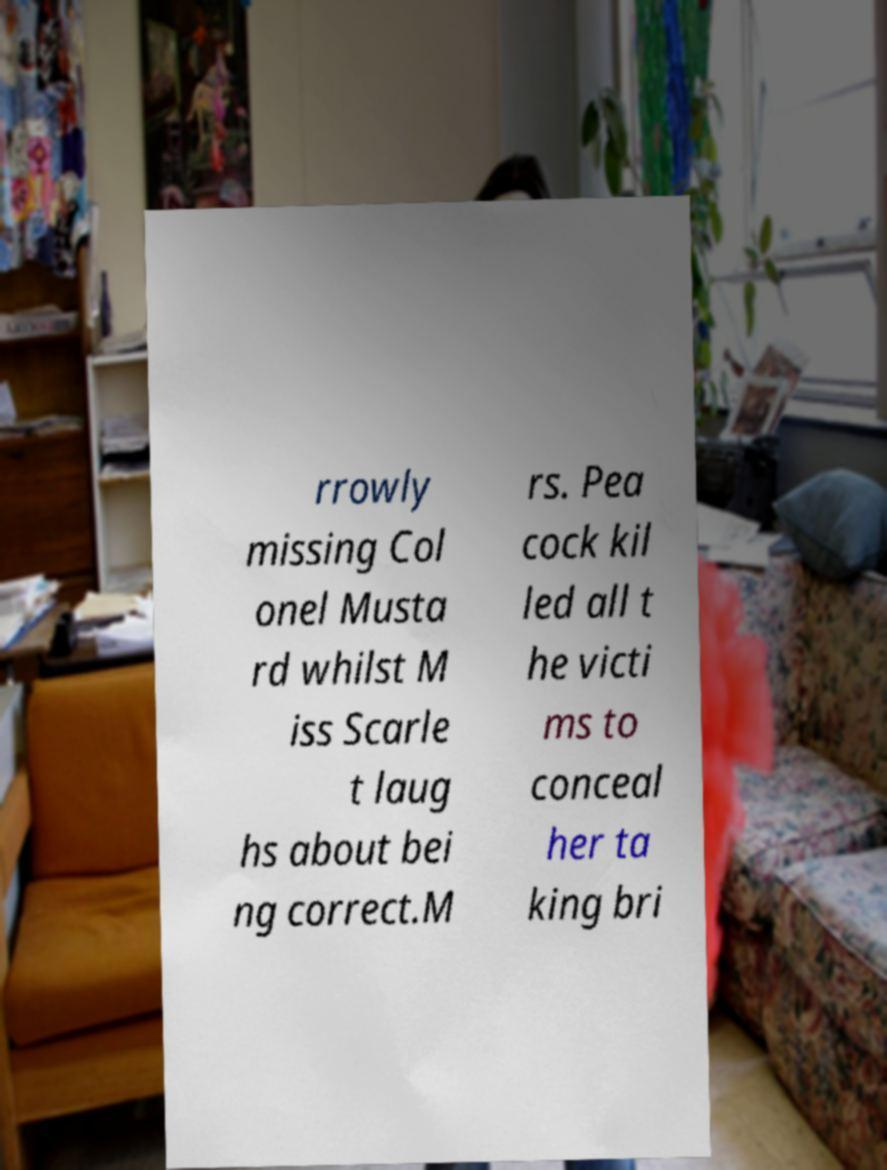Can you read and provide the text displayed in the image?This photo seems to have some interesting text. Can you extract and type it out for me? rrowly missing Col onel Musta rd whilst M iss Scarle t laug hs about bei ng correct.M rs. Pea cock kil led all t he victi ms to conceal her ta king bri 